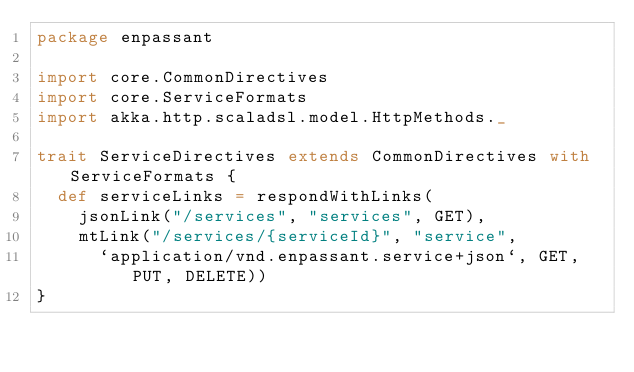<code> <loc_0><loc_0><loc_500><loc_500><_Scala_>package enpassant

import core.CommonDirectives
import core.ServiceFormats
import akka.http.scaladsl.model.HttpMethods._

trait ServiceDirectives extends CommonDirectives with ServiceFormats {
  def serviceLinks = respondWithLinks(
    jsonLink("/services", "services", GET),
    mtLink("/services/{serviceId}", "service",
      `application/vnd.enpassant.service+json`, GET, PUT, DELETE))
}
</code> 